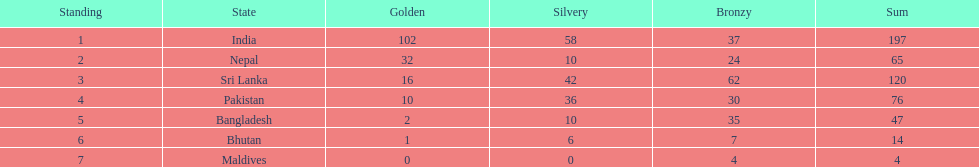What are the total number of bronze medals sri lanka have earned? 62. 